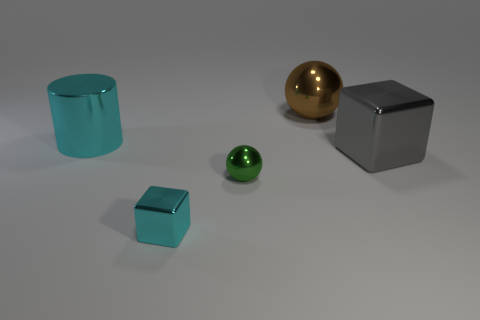Add 1 gray metal cubes. How many objects exist? 6 Subtract all cylinders. How many objects are left? 4 Subtract all large green matte cubes. Subtract all large metallic balls. How many objects are left? 4 Add 4 big shiny cylinders. How many big shiny cylinders are left? 5 Add 3 blue cylinders. How many blue cylinders exist? 3 Subtract 0 gray cylinders. How many objects are left? 5 